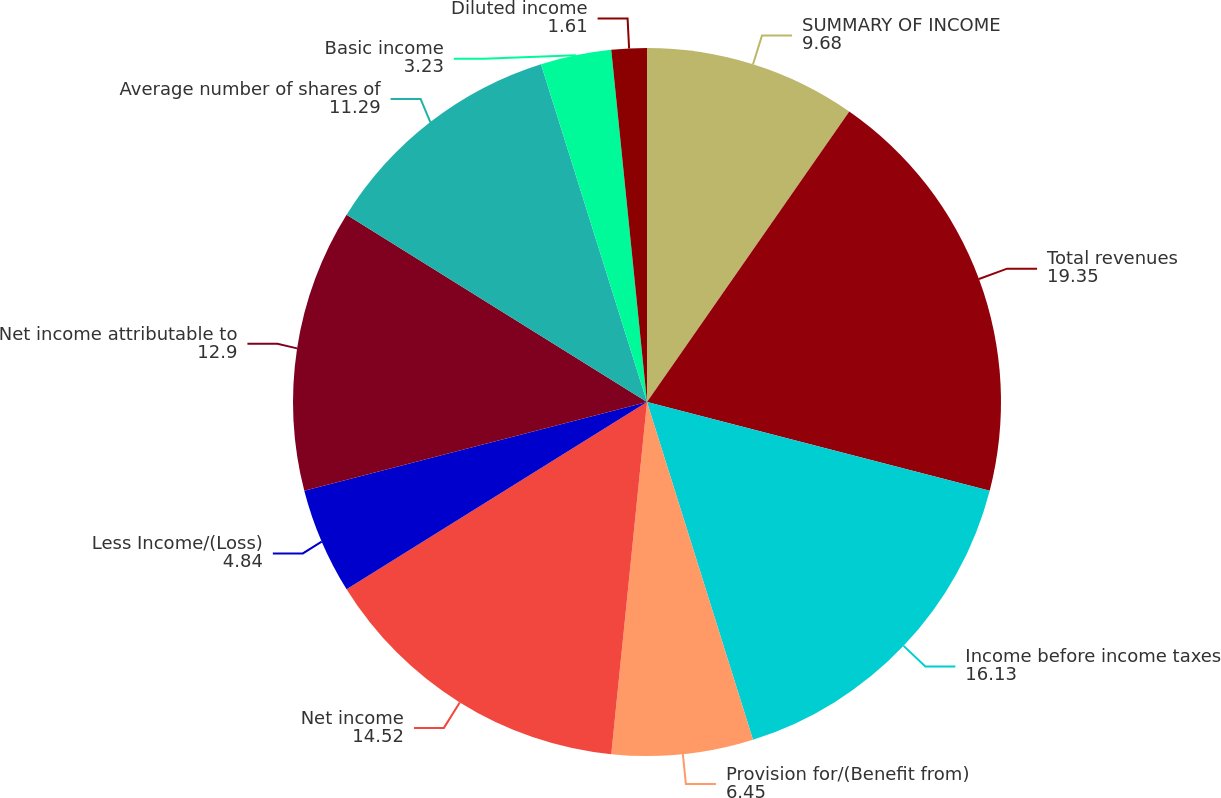<chart> <loc_0><loc_0><loc_500><loc_500><pie_chart><fcel>SUMMARY OF INCOME<fcel>Total revenues<fcel>Income before income taxes<fcel>Provision for/(Benefit from)<fcel>Net income<fcel>Less Income/(Loss)<fcel>Net income attributable to<fcel>Average number of shares of<fcel>Basic income<fcel>Diluted income<nl><fcel>9.68%<fcel>19.35%<fcel>16.13%<fcel>6.45%<fcel>14.52%<fcel>4.84%<fcel>12.9%<fcel>11.29%<fcel>3.23%<fcel>1.61%<nl></chart> 